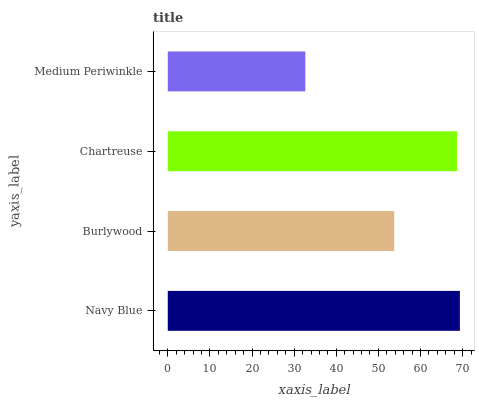Is Medium Periwinkle the minimum?
Answer yes or no. Yes. Is Navy Blue the maximum?
Answer yes or no. Yes. Is Burlywood the minimum?
Answer yes or no. No. Is Burlywood the maximum?
Answer yes or no. No. Is Navy Blue greater than Burlywood?
Answer yes or no. Yes. Is Burlywood less than Navy Blue?
Answer yes or no. Yes. Is Burlywood greater than Navy Blue?
Answer yes or no. No. Is Navy Blue less than Burlywood?
Answer yes or no. No. Is Chartreuse the high median?
Answer yes or no. Yes. Is Burlywood the low median?
Answer yes or no. Yes. Is Navy Blue the high median?
Answer yes or no. No. Is Navy Blue the low median?
Answer yes or no. No. 